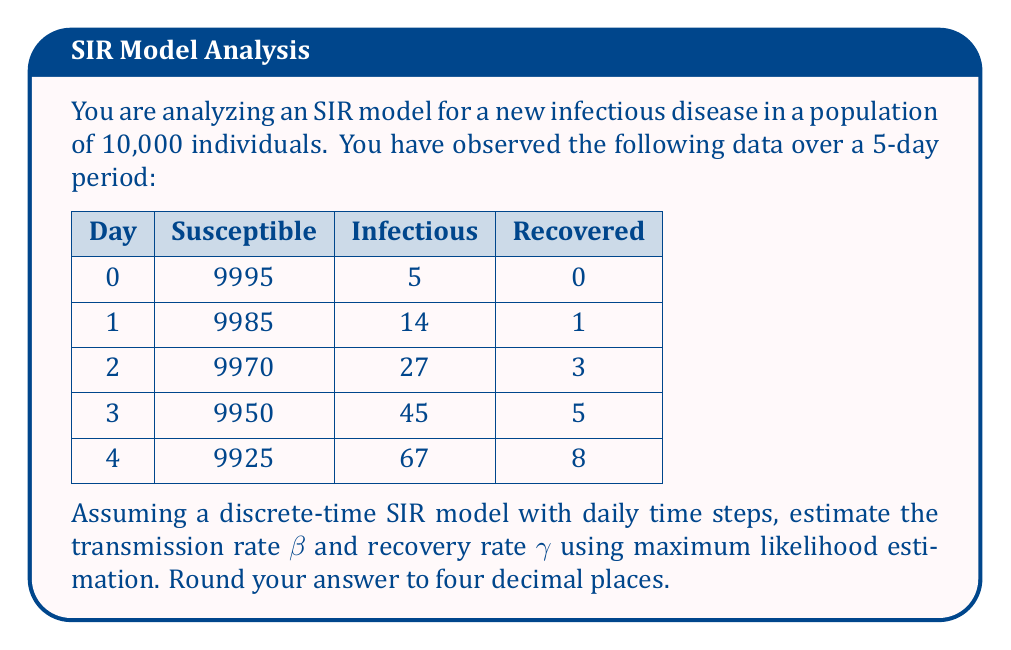Solve this math problem. To estimate the parameters of the SIR model using maximum likelihood, we need to follow these steps:

1) First, let's recall the discrete-time SIR model equations:

   $$S_{t+1} = S_t - \beta S_t I_t / N$$
   $$I_{t+1} = I_t + \beta S_t I_t / N - \gamma I_t$$
   $$R_{t+1} = R_t + \gamma I_t$$

   where $N$ is the total population.

2) The likelihood function for this model, assuming Poisson-distributed transitions, is:

   $$L(\beta, \gamma) = \prod_{t=0}^{T-1} \text{Poisson}(S_t - S_{t+1}; \lambda = \beta S_t I_t / N) \cdot \text{Poisson}(R_{t+1} - R_t; \lambda = \gamma I_t)$$

3) Taking the log of this function gives us the log-likelihood:

   $$\log L(\beta, \gamma) = \sum_{t=0}^{T-1} [(S_t - S_{t+1}) \log(\beta S_t I_t / N) - \beta S_t I_t / N] + [(R_{t+1} - R_t) \log(\gamma I_t) - \gamma I_t] + C$$

   where $C$ is a constant term.

4) To maximize this, we need to find the partial derivatives with respect to $\beta$ and $\gamma$ and set them to zero:

   $$\frac{\partial \log L}{\partial \beta} = \sum_{t=0}^{T-1} \frac{S_t - S_{t+1}}{\beta} - S_t I_t / N = 0$$
   
   $$\frac{\partial \log L}{\partial \gamma} = \sum_{t=0}^{T-1} \frac{R_{t+1} - R_t}{\gamma} - I_t = 0$$

5) Solving these equations:

   $$\hat{\beta} = N \cdot \frac{\sum_{t=0}^{T-1} (S_t - S_{t+1})}{\sum_{t=0}^{T-1} S_t I_t}$$
   
   $$\hat{\gamma} = \frac{\sum_{t=0}^{T-1} (R_{t+1} - R_t)}{\sum_{t=0}^{T-1} I_t}$$

6) Now, let's calculate these values using our data:

   $$\sum_{t=0}^{T-1} (S_t - S_{t+1}) = 70$$
   $$\sum_{t=0}^{T-1} S_t I_t = 1,490,380$$
   $$\sum_{t=0}^{T-1} (R_{t+1} - R_t) = 8$$
   $$\sum_{t=0}^{T-1} I_t = 91$$

7) Plugging these into our formulas:

   $$\hat{\beta} = 10,000 \cdot \frac{70}{1,490,380} = 0.4697$$
   
   $$\hat{\gamma} = \frac{8}{91} = 0.0879$$

8) Rounding to four decimal places gives us our final estimates.
Answer: $\hat{\beta} = 0.4697$, $\hat{\gamma} = 0.0879$ 